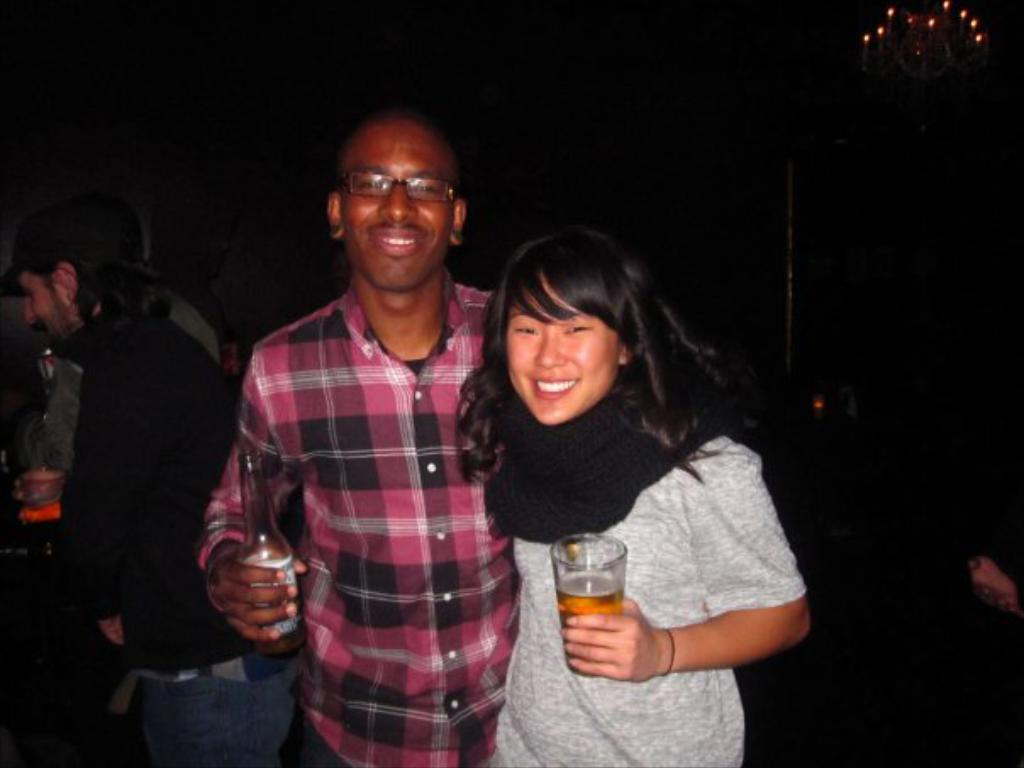What is the main subject of the image? The main subject of the image is a couple standing together. Is there anyone else in the image besides the couple? Yes, there is a person standing on the left side of the image. What can be observed about the background of the image? The background of the image is dark. What type of arch can be seen in the background of the image? There is no arch present in the image; the background is dark. Can you tell me how many aunts are visible in the image? There is no aunt present in the image; it features a couple and a person standing on the left side. 